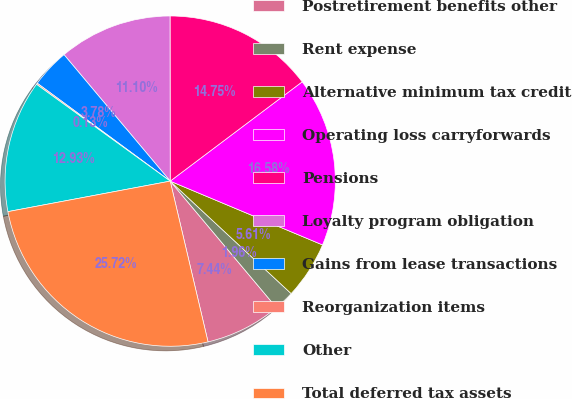Convert chart. <chart><loc_0><loc_0><loc_500><loc_500><pie_chart><fcel>Postretirement benefits other<fcel>Rent expense<fcel>Alternative minimum tax credit<fcel>Operating loss carryforwards<fcel>Pensions<fcel>Loyalty program obligation<fcel>Gains from lease transactions<fcel>Reorganization items<fcel>Other<fcel>Total deferred tax assets<nl><fcel>7.44%<fcel>1.96%<fcel>5.61%<fcel>16.58%<fcel>14.75%<fcel>11.1%<fcel>3.78%<fcel>0.13%<fcel>12.93%<fcel>25.72%<nl></chart> 